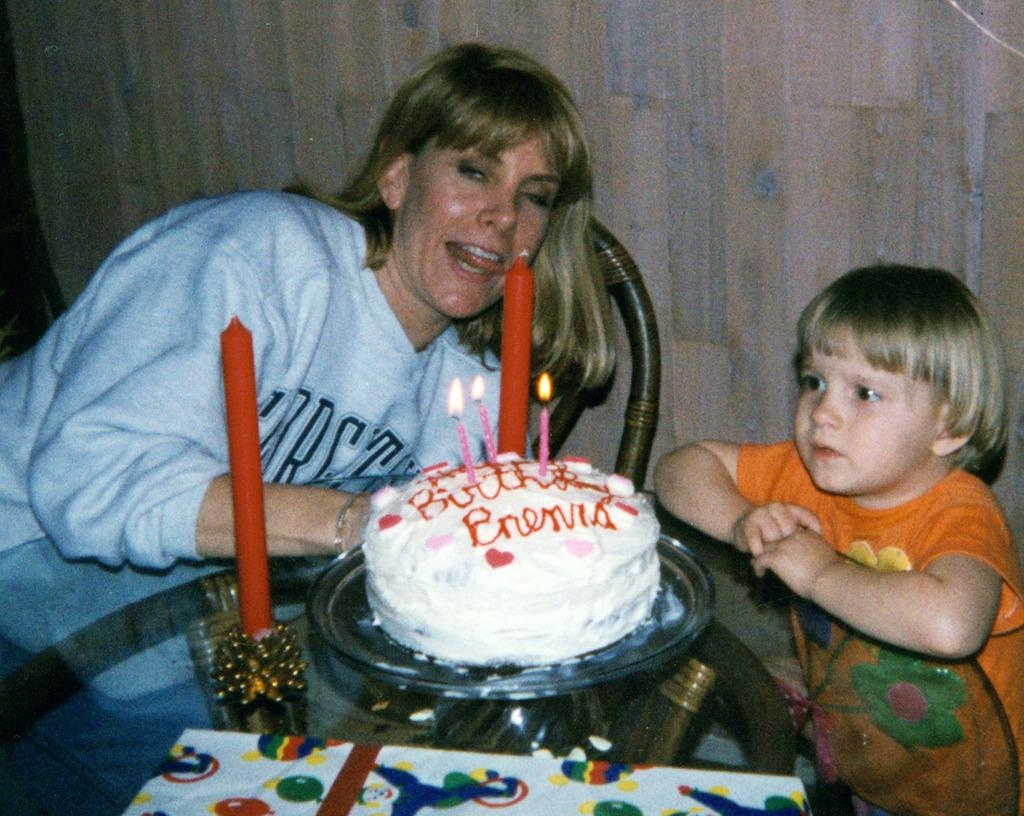Who are the people in the image? There is a woman and a girl in the image. What are they doing in the image? Both the woman and the girl are at a table. What objects can be seen on the table? There are candles and a cake on a plate with candles on it. What is visible in the background of the image? There is a wall and a chair in the background of the image. How many baseballs can be seen in the image? There are no baseballs present in the image. What type of earthquake is depicted in the image? There is no earthquake depicted in the image. 